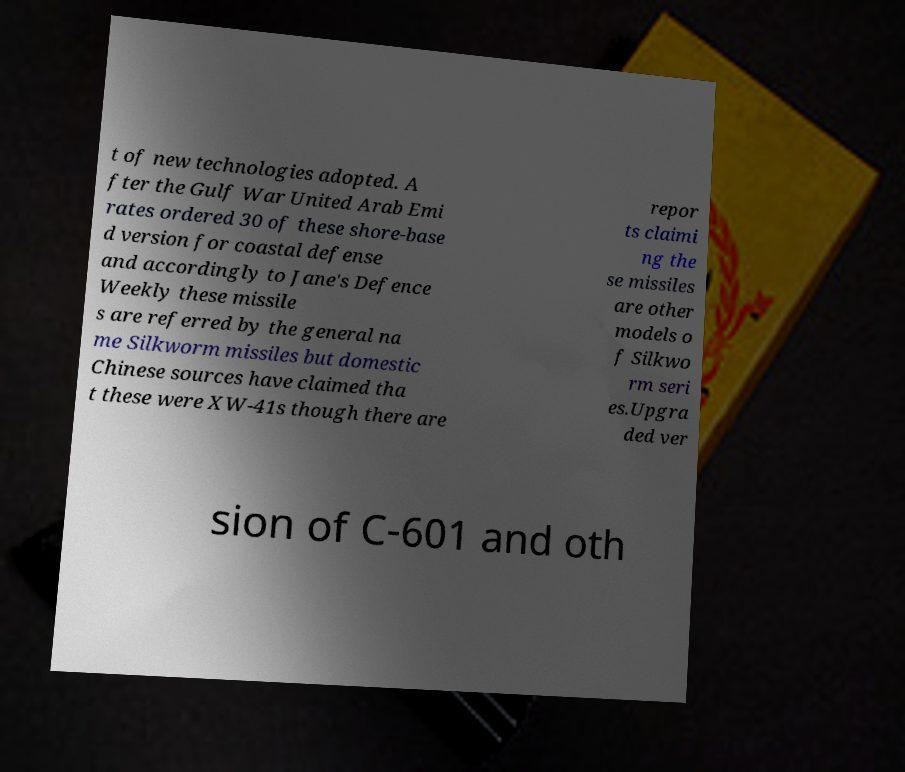There's text embedded in this image that I need extracted. Can you transcribe it verbatim? t of new technologies adopted. A fter the Gulf War United Arab Emi rates ordered 30 of these shore-base d version for coastal defense and accordingly to Jane's Defence Weekly these missile s are referred by the general na me Silkworm missiles but domestic Chinese sources have claimed tha t these were XW-41s though there are repor ts claimi ng the se missiles are other models o f Silkwo rm seri es.Upgra ded ver sion of C-601 and oth 